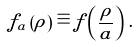Convert formula to latex. <formula><loc_0><loc_0><loc_500><loc_500>f _ { a } \left ( \rho \right ) \equiv f \left ( \frac { \rho } { a } \right ) \, .</formula> 